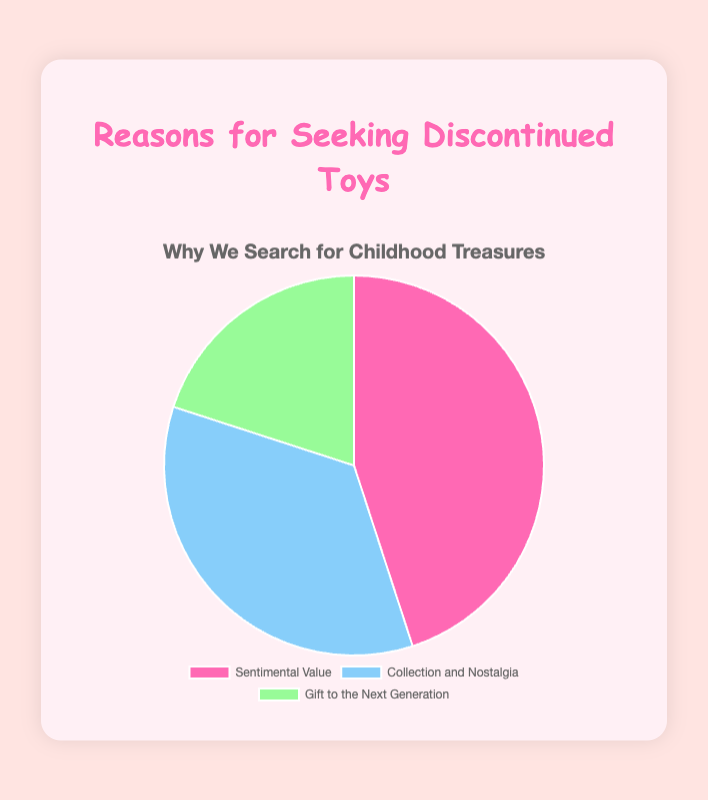What is the most common reason people seek out discontinued toys? The segment labeled "Sentimental Value" occupies the largest portion of the pie chart. This indicates it is the most common reason.
Answer: Sentimental Value Which reason is the least common for seeking out discontinued toys? The smallest segment on the pie chart corresponds to the reason labeled "Gift to the Next Generation". This indicates it is the least common reason.
Answer: Gift to the Next Generation How much larger is the percentage for Sentimental Value compared to Gift to the Next Generation? The percentage for Sentimental Value is 45%, and the percentage for Gift to the Next Generation is 20%. The difference is 45% - 20% = 25%.
Answer: 25% What combined percentage of people seek discontinued toys for Sentimental Value and Collection and Nostalgia? Add the percentages for Sentimental Value (45%) and Collection and Nostalgia (35%). The sum is 45% + 35% = 80%.
Answer: 80% Which reason appears in green on the pie chart? The "Gift to the Next Generation" segment is colored green in the pie chart.
Answer: Gift to the Next Generation Between Collection and Nostalgia and Gift to the Next Generation, which reason has a higher percentage and by how much? The percentage for Collection and Nostalgia is 35%, and for Gift to the Next Generation, it is 20%. The difference is 35% - 20% = 15%.
Answer: Collection and Nostalgia, 15% If the "Collection and Nostalgia" category were to increase by 10 percentage points, would it become the most common reason? Currently, Collection and Nostalgia is at 35%. If it increases by 10%, it becomes 45%. The Sentimental Value is also 45%. Hence, they would be equal and it will not surpass Sentimental Value.
Answer: No, it would be equal to Sentimental Value 